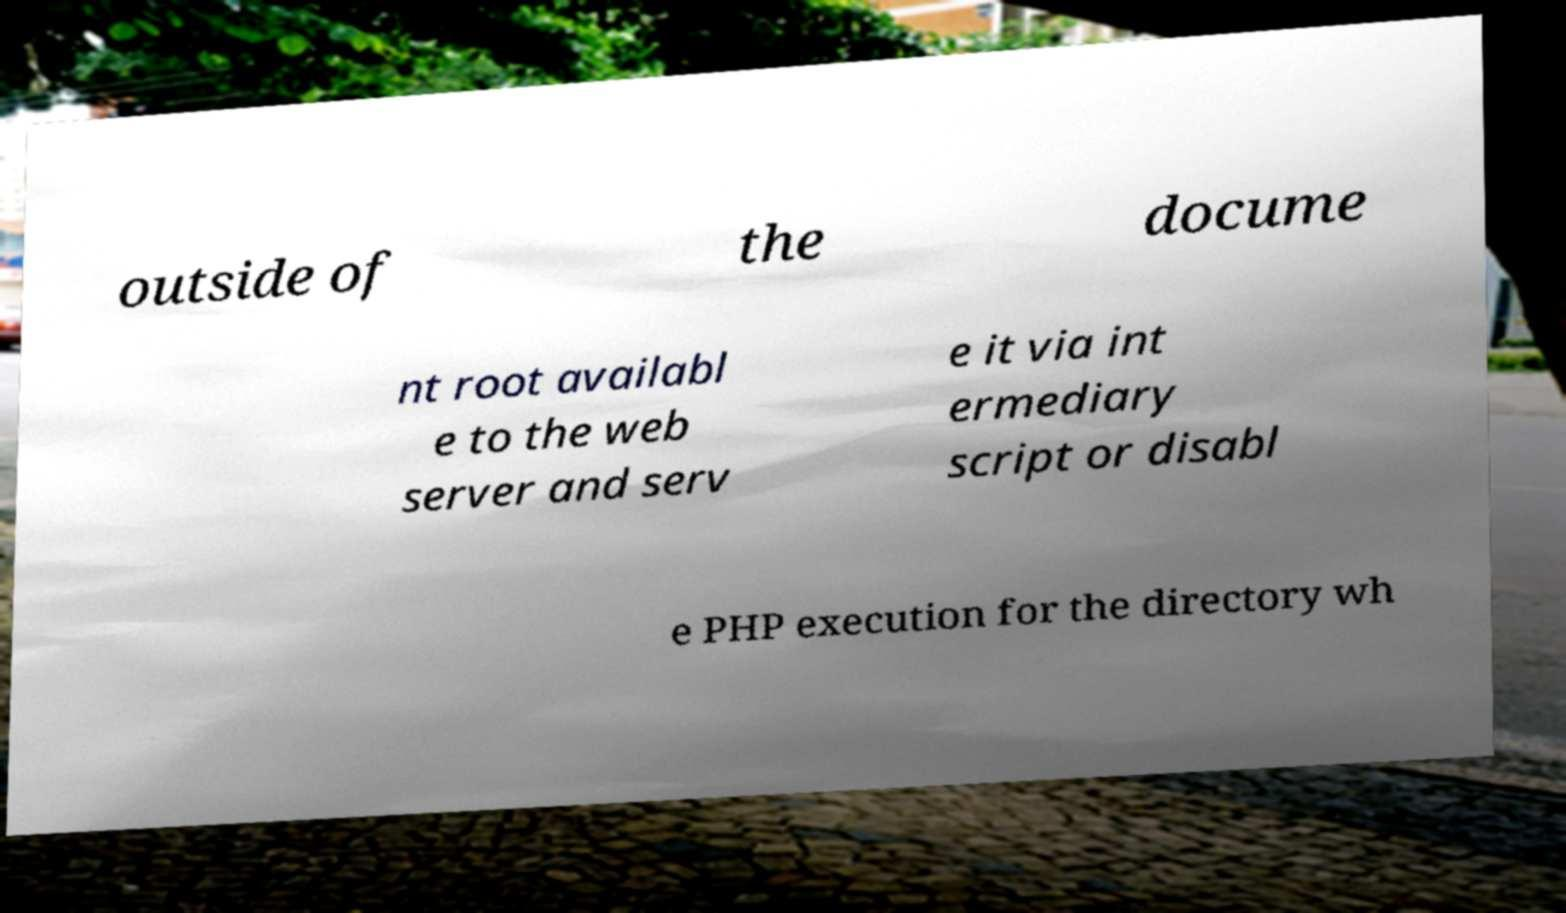Could you assist in decoding the text presented in this image and type it out clearly? outside of the docume nt root availabl e to the web server and serv e it via int ermediary script or disabl e PHP execution for the directory wh 